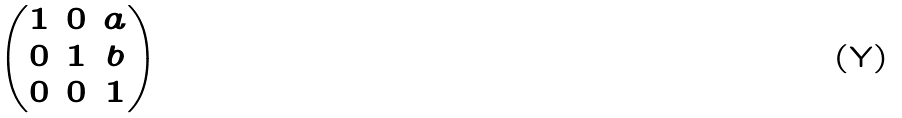<formula> <loc_0><loc_0><loc_500><loc_500>\begin{pmatrix} 1 & 0 & a \\ 0 & 1 & b \\ 0 & 0 & 1 \end{pmatrix}</formula> 